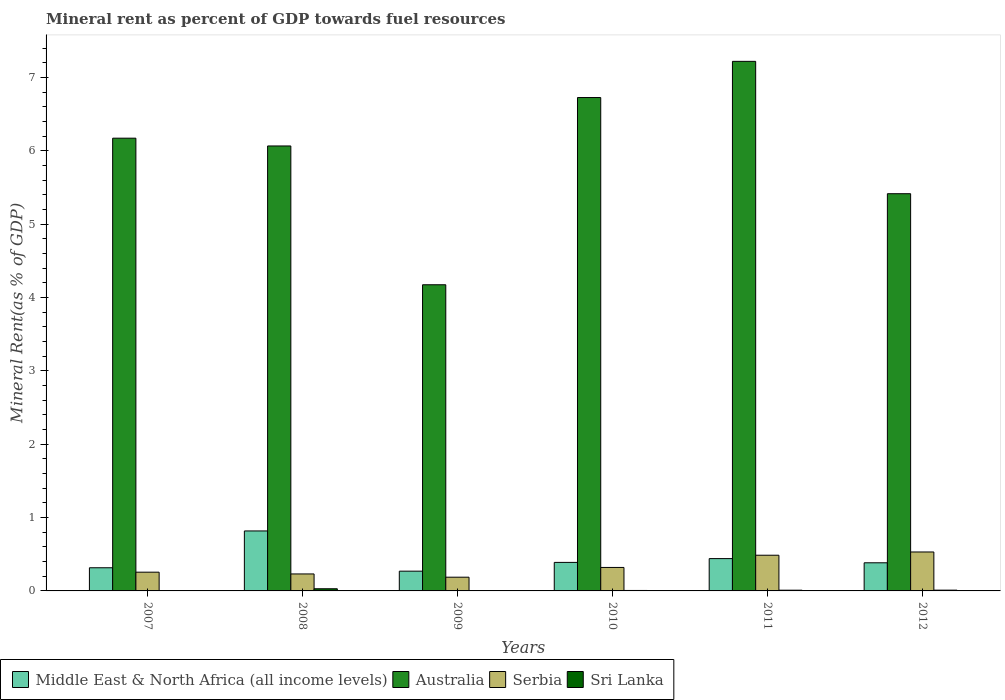How many different coloured bars are there?
Give a very brief answer. 4. Are the number of bars per tick equal to the number of legend labels?
Provide a short and direct response. Yes. How many bars are there on the 3rd tick from the right?
Offer a terse response. 4. What is the label of the 5th group of bars from the left?
Your response must be concise. 2011. In how many cases, is the number of bars for a given year not equal to the number of legend labels?
Your answer should be very brief. 0. What is the mineral rent in Australia in 2009?
Keep it short and to the point. 4.17. Across all years, what is the maximum mineral rent in Middle East & North Africa (all income levels)?
Your answer should be very brief. 0.82. Across all years, what is the minimum mineral rent in Australia?
Give a very brief answer. 4.17. In which year was the mineral rent in Australia maximum?
Keep it short and to the point. 2011. What is the total mineral rent in Middle East & North Africa (all income levels) in the graph?
Provide a succinct answer. 2.62. What is the difference between the mineral rent in Serbia in 2008 and that in 2012?
Keep it short and to the point. -0.3. What is the difference between the mineral rent in Australia in 2011 and the mineral rent in Middle East & North Africa (all income levels) in 2008?
Your answer should be very brief. 6.4. What is the average mineral rent in Sri Lanka per year?
Provide a short and direct response. 0.01. In the year 2009, what is the difference between the mineral rent in Australia and mineral rent in Serbia?
Offer a very short reply. 3.99. What is the ratio of the mineral rent in Serbia in 2007 to that in 2012?
Provide a succinct answer. 0.48. What is the difference between the highest and the second highest mineral rent in Sri Lanka?
Your answer should be very brief. 0.02. What is the difference between the highest and the lowest mineral rent in Sri Lanka?
Offer a terse response. 0.03. Is the sum of the mineral rent in Australia in 2010 and 2011 greater than the maximum mineral rent in Middle East & North Africa (all income levels) across all years?
Your response must be concise. Yes. Is it the case that in every year, the sum of the mineral rent in Middle East & North Africa (all income levels) and mineral rent in Sri Lanka is greater than the sum of mineral rent in Australia and mineral rent in Serbia?
Keep it short and to the point. No. What does the 1st bar from the left in 2010 represents?
Provide a succinct answer. Middle East & North Africa (all income levels). What does the 4th bar from the right in 2012 represents?
Provide a short and direct response. Middle East & North Africa (all income levels). How many bars are there?
Your answer should be very brief. 24. Are all the bars in the graph horizontal?
Provide a succinct answer. No. How many years are there in the graph?
Offer a very short reply. 6. What is the difference between two consecutive major ticks on the Y-axis?
Offer a terse response. 1. Does the graph contain any zero values?
Your answer should be very brief. No. Does the graph contain grids?
Your answer should be very brief. No. Where does the legend appear in the graph?
Your answer should be compact. Bottom left. How are the legend labels stacked?
Ensure brevity in your answer.  Horizontal. What is the title of the graph?
Provide a short and direct response. Mineral rent as percent of GDP towards fuel resources. Does "Ecuador" appear as one of the legend labels in the graph?
Provide a short and direct response. No. What is the label or title of the Y-axis?
Your answer should be very brief. Mineral Rent(as % of GDP). What is the Mineral Rent(as % of GDP) of Middle East & North Africa (all income levels) in 2007?
Offer a very short reply. 0.32. What is the Mineral Rent(as % of GDP) of Australia in 2007?
Give a very brief answer. 6.17. What is the Mineral Rent(as % of GDP) in Serbia in 2007?
Keep it short and to the point. 0.26. What is the Mineral Rent(as % of GDP) of Sri Lanka in 2007?
Your answer should be very brief. 0. What is the Mineral Rent(as % of GDP) of Middle East & North Africa (all income levels) in 2008?
Keep it short and to the point. 0.82. What is the Mineral Rent(as % of GDP) in Australia in 2008?
Provide a succinct answer. 6.06. What is the Mineral Rent(as % of GDP) in Serbia in 2008?
Your response must be concise. 0.23. What is the Mineral Rent(as % of GDP) in Sri Lanka in 2008?
Make the answer very short. 0.03. What is the Mineral Rent(as % of GDP) of Middle East & North Africa (all income levels) in 2009?
Ensure brevity in your answer.  0.27. What is the Mineral Rent(as % of GDP) of Australia in 2009?
Your response must be concise. 4.17. What is the Mineral Rent(as % of GDP) of Serbia in 2009?
Ensure brevity in your answer.  0.19. What is the Mineral Rent(as % of GDP) in Sri Lanka in 2009?
Ensure brevity in your answer.  0.01. What is the Mineral Rent(as % of GDP) of Middle East & North Africa (all income levels) in 2010?
Your answer should be compact. 0.39. What is the Mineral Rent(as % of GDP) in Australia in 2010?
Give a very brief answer. 6.72. What is the Mineral Rent(as % of GDP) of Serbia in 2010?
Provide a short and direct response. 0.32. What is the Mineral Rent(as % of GDP) in Sri Lanka in 2010?
Keep it short and to the point. 0.01. What is the Mineral Rent(as % of GDP) in Middle East & North Africa (all income levels) in 2011?
Offer a very short reply. 0.44. What is the Mineral Rent(as % of GDP) of Australia in 2011?
Offer a terse response. 7.22. What is the Mineral Rent(as % of GDP) of Serbia in 2011?
Offer a very short reply. 0.49. What is the Mineral Rent(as % of GDP) in Sri Lanka in 2011?
Ensure brevity in your answer.  0.01. What is the Mineral Rent(as % of GDP) of Middle East & North Africa (all income levels) in 2012?
Make the answer very short. 0.38. What is the Mineral Rent(as % of GDP) in Australia in 2012?
Make the answer very short. 5.41. What is the Mineral Rent(as % of GDP) in Serbia in 2012?
Give a very brief answer. 0.53. What is the Mineral Rent(as % of GDP) of Sri Lanka in 2012?
Give a very brief answer. 0.01. Across all years, what is the maximum Mineral Rent(as % of GDP) of Middle East & North Africa (all income levels)?
Offer a terse response. 0.82. Across all years, what is the maximum Mineral Rent(as % of GDP) of Australia?
Your response must be concise. 7.22. Across all years, what is the maximum Mineral Rent(as % of GDP) in Serbia?
Provide a short and direct response. 0.53. Across all years, what is the maximum Mineral Rent(as % of GDP) in Sri Lanka?
Your answer should be very brief. 0.03. Across all years, what is the minimum Mineral Rent(as % of GDP) in Middle East & North Africa (all income levels)?
Keep it short and to the point. 0.27. Across all years, what is the minimum Mineral Rent(as % of GDP) of Australia?
Offer a terse response. 4.17. Across all years, what is the minimum Mineral Rent(as % of GDP) of Serbia?
Keep it short and to the point. 0.19. Across all years, what is the minimum Mineral Rent(as % of GDP) in Sri Lanka?
Offer a terse response. 0. What is the total Mineral Rent(as % of GDP) in Middle East & North Africa (all income levels) in the graph?
Offer a very short reply. 2.62. What is the total Mineral Rent(as % of GDP) in Australia in the graph?
Ensure brevity in your answer.  35.77. What is the total Mineral Rent(as % of GDP) of Serbia in the graph?
Give a very brief answer. 2.01. What is the total Mineral Rent(as % of GDP) of Sri Lanka in the graph?
Your response must be concise. 0.06. What is the difference between the Mineral Rent(as % of GDP) of Middle East & North Africa (all income levels) in 2007 and that in 2008?
Make the answer very short. -0.5. What is the difference between the Mineral Rent(as % of GDP) in Australia in 2007 and that in 2008?
Offer a terse response. 0.11. What is the difference between the Mineral Rent(as % of GDP) of Serbia in 2007 and that in 2008?
Keep it short and to the point. 0.02. What is the difference between the Mineral Rent(as % of GDP) in Sri Lanka in 2007 and that in 2008?
Your answer should be compact. -0.03. What is the difference between the Mineral Rent(as % of GDP) in Middle East & North Africa (all income levels) in 2007 and that in 2009?
Make the answer very short. 0.05. What is the difference between the Mineral Rent(as % of GDP) of Australia in 2007 and that in 2009?
Offer a very short reply. 2. What is the difference between the Mineral Rent(as % of GDP) of Serbia in 2007 and that in 2009?
Your response must be concise. 0.07. What is the difference between the Mineral Rent(as % of GDP) of Sri Lanka in 2007 and that in 2009?
Make the answer very short. -0. What is the difference between the Mineral Rent(as % of GDP) in Middle East & North Africa (all income levels) in 2007 and that in 2010?
Offer a very short reply. -0.07. What is the difference between the Mineral Rent(as % of GDP) in Australia in 2007 and that in 2010?
Your answer should be very brief. -0.55. What is the difference between the Mineral Rent(as % of GDP) of Serbia in 2007 and that in 2010?
Give a very brief answer. -0.06. What is the difference between the Mineral Rent(as % of GDP) in Sri Lanka in 2007 and that in 2010?
Offer a very short reply. -0. What is the difference between the Mineral Rent(as % of GDP) in Middle East & North Africa (all income levels) in 2007 and that in 2011?
Provide a short and direct response. -0.12. What is the difference between the Mineral Rent(as % of GDP) in Australia in 2007 and that in 2011?
Your response must be concise. -1.05. What is the difference between the Mineral Rent(as % of GDP) of Serbia in 2007 and that in 2011?
Your answer should be very brief. -0.23. What is the difference between the Mineral Rent(as % of GDP) of Sri Lanka in 2007 and that in 2011?
Your answer should be compact. -0.01. What is the difference between the Mineral Rent(as % of GDP) of Middle East & North Africa (all income levels) in 2007 and that in 2012?
Ensure brevity in your answer.  -0.07. What is the difference between the Mineral Rent(as % of GDP) of Australia in 2007 and that in 2012?
Offer a very short reply. 0.76. What is the difference between the Mineral Rent(as % of GDP) of Serbia in 2007 and that in 2012?
Provide a succinct answer. -0.28. What is the difference between the Mineral Rent(as % of GDP) in Sri Lanka in 2007 and that in 2012?
Ensure brevity in your answer.  -0.01. What is the difference between the Mineral Rent(as % of GDP) in Middle East & North Africa (all income levels) in 2008 and that in 2009?
Offer a very short reply. 0.55. What is the difference between the Mineral Rent(as % of GDP) of Australia in 2008 and that in 2009?
Keep it short and to the point. 1.89. What is the difference between the Mineral Rent(as % of GDP) of Serbia in 2008 and that in 2009?
Keep it short and to the point. 0.04. What is the difference between the Mineral Rent(as % of GDP) in Sri Lanka in 2008 and that in 2009?
Your response must be concise. 0.02. What is the difference between the Mineral Rent(as % of GDP) in Middle East & North Africa (all income levels) in 2008 and that in 2010?
Your answer should be compact. 0.43. What is the difference between the Mineral Rent(as % of GDP) in Australia in 2008 and that in 2010?
Your response must be concise. -0.66. What is the difference between the Mineral Rent(as % of GDP) of Serbia in 2008 and that in 2010?
Give a very brief answer. -0.09. What is the difference between the Mineral Rent(as % of GDP) in Sri Lanka in 2008 and that in 2010?
Provide a short and direct response. 0.02. What is the difference between the Mineral Rent(as % of GDP) of Middle East & North Africa (all income levels) in 2008 and that in 2011?
Offer a terse response. 0.38. What is the difference between the Mineral Rent(as % of GDP) of Australia in 2008 and that in 2011?
Give a very brief answer. -1.15. What is the difference between the Mineral Rent(as % of GDP) of Serbia in 2008 and that in 2011?
Keep it short and to the point. -0.26. What is the difference between the Mineral Rent(as % of GDP) in Sri Lanka in 2008 and that in 2011?
Your response must be concise. 0.02. What is the difference between the Mineral Rent(as % of GDP) of Middle East & North Africa (all income levels) in 2008 and that in 2012?
Offer a very short reply. 0.43. What is the difference between the Mineral Rent(as % of GDP) of Australia in 2008 and that in 2012?
Your response must be concise. 0.65. What is the difference between the Mineral Rent(as % of GDP) of Serbia in 2008 and that in 2012?
Give a very brief answer. -0.3. What is the difference between the Mineral Rent(as % of GDP) in Sri Lanka in 2008 and that in 2012?
Offer a very short reply. 0.02. What is the difference between the Mineral Rent(as % of GDP) in Middle East & North Africa (all income levels) in 2009 and that in 2010?
Ensure brevity in your answer.  -0.12. What is the difference between the Mineral Rent(as % of GDP) in Australia in 2009 and that in 2010?
Your response must be concise. -2.55. What is the difference between the Mineral Rent(as % of GDP) of Serbia in 2009 and that in 2010?
Make the answer very short. -0.13. What is the difference between the Mineral Rent(as % of GDP) in Sri Lanka in 2009 and that in 2010?
Your answer should be compact. -0. What is the difference between the Mineral Rent(as % of GDP) of Middle East & North Africa (all income levels) in 2009 and that in 2011?
Give a very brief answer. -0.17. What is the difference between the Mineral Rent(as % of GDP) in Australia in 2009 and that in 2011?
Make the answer very short. -3.05. What is the difference between the Mineral Rent(as % of GDP) of Serbia in 2009 and that in 2011?
Provide a succinct answer. -0.3. What is the difference between the Mineral Rent(as % of GDP) of Sri Lanka in 2009 and that in 2011?
Give a very brief answer. -0. What is the difference between the Mineral Rent(as % of GDP) of Middle East & North Africa (all income levels) in 2009 and that in 2012?
Provide a succinct answer. -0.11. What is the difference between the Mineral Rent(as % of GDP) in Australia in 2009 and that in 2012?
Ensure brevity in your answer.  -1.24. What is the difference between the Mineral Rent(as % of GDP) of Serbia in 2009 and that in 2012?
Your answer should be compact. -0.34. What is the difference between the Mineral Rent(as % of GDP) of Sri Lanka in 2009 and that in 2012?
Keep it short and to the point. -0. What is the difference between the Mineral Rent(as % of GDP) of Middle East & North Africa (all income levels) in 2010 and that in 2011?
Keep it short and to the point. -0.05. What is the difference between the Mineral Rent(as % of GDP) of Australia in 2010 and that in 2011?
Your answer should be compact. -0.49. What is the difference between the Mineral Rent(as % of GDP) in Serbia in 2010 and that in 2011?
Offer a very short reply. -0.17. What is the difference between the Mineral Rent(as % of GDP) in Sri Lanka in 2010 and that in 2011?
Offer a very short reply. -0. What is the difference between the Mineral Rent(as % of GDP) of Middle East & North Africa (all income levels) in 2010 and that in 2012?
Ensure brevity in your answer.  0.01. What is the difference between the Mineral Rent(as % of GDP) of Australia in 2010 and that in 2012?
Keep it short and to the point. 1.31. What is the difference between the Mineral Rent(as % of GDP) of Serbia in 2010 and that in 2012?
Make the answer very short. -0.21. What is the difference between the Mineral Rent(as % of GDP) of Sri Lanka in 2010 and that in 2012?
Your response must be concise. -0. What is the difference between the Mineral Rent(as % of GDP) of Middle East & North Africa (all income levels) in 2011 and that in 2012?
Your answer should be very brief. 0.06. What is the difference between the Mineral Rent(as % of GDP) in Australia in 2011 and that in 2012?
Ensure brevity in your answer.  1.8. What is the difference between the Mineral Rent(as % of GDP) in Serbia in 2011 and that in 2012?
Your answer should be very brief. -0.04. What is the difference between the Mineral Rent(as % of GDP) in Sri Lanka in 2011 and that in 2012?
Ensure brevity in your answer.  -0. What is the difference between the Mineral Rent(as % of GDP) in Middle East & North Africa (all income levels) in 2007 and the Mineral Rent(as % of GDP) in Australia in 2008?
Your answer should be compact. -5.75. What is the difference between the Mineral Rent(as % of GDP) of Middle East & North Africa (all income levels) in 2007 and the Mineral Rent(as % of GDP) of Serbia in 2008?
Give a very brief answer. 0.08. What is the difference between the Mineral Rent(as % of GDP) in Middle East & North Africa (all income levels) in 2007 and the Mineral Rent(as % of GDP) in Sri Lanka in 2008?
Ensure brevity in your answer.  0.29. What is the difference between the Mineral Rent(as % of GDP) of Australia in 2007 and the Mineral Rent(as % of GDP) of Serbia in 2008?
Give a very brief answer. 5.94. What is the difference between the Mineral Rent(as % of GDP) of Australia in 2007 and the Mineral Rent(as % of GDP) of Sri Lanka in 2008?
Offer a very short reply. 6.14. What is the difference between the Mineral Rent(as % of GDP) in Serbia in 2007 and the Mineral Rent(as % of GDP) in Sri Lanka in 2008?
Provide a short and direct response. 0.23. What is the difference between the Mineral Rent(as % of GDP) of Middle East & North Africa (all income levels) in 2007 and the Mineral Rent(as % of GDP) of Australia in 2009?
Your response must be concise. -3.86. What is the difference between the Mineral Rent(as % of GDP) of Middle East & North Africa (all income levels) in 2007 and the Mineral Rent(as % of GDP) of Serbia in 2009?
Your answer should be very brief. 0.13. What is the difference between the Mineral Rent(as % of GDP) of Middle East & North Africa (all income levels) in 2007 and the Mineral Rent(as % of GDP) of Sri Lanka in 2009?
Your answer should be compact. 0.31. What is the difference between the Mineral Rent(as % of GDP) of Australia in 2007 and the Mineral Rent(as % of GDP) of Serbia in 2009?
Keep it short and to the point. 5.98. What is the difference between the Mineral Rent(as % of GDP) of Australia in 2007 and the Mineral Rent(as % of GDP) of Sri Lanka in 2009?
Offer a very short reply. 6.17. What is the difference between the Mineral Rent(as % of GDP) of Serbia in 2007 and the Mineral Rent(as % of GDP) of Sri Lanka in 2009?
Keep it short and to the point. 0.25. What is the difference between the Mineral Rent(as % of GDP) of Middle East & North Africa (all income levels) in 2007 and the Mineral Rent(as % of GDP) of Australia in 2010?
Keep it short and to the point. -6.41. What is the difference between the Mineral Rent(as % of GDP) of Middle East & North Africa (all income levels) in 2007 and the Mineral Rent(as % of GDP) of Serbia in 2010?
Ensure brevity in your answer.  -0. What is the difference between the Mineral Rent(as % of GDP) in Middle East & North Africa (all income levels) in 2007 and the Mineral Rent(as % of GDP) in Sri Lanka in 2010?
Provide a short and direct response. 0.31. What is the difference between the Mineral Rent(as % of GDP) of Australia in 2007 and the Mineral Rent(as % of GDP) of Serbia in 2010?
Offer a very short reply. 5.85. What is the difference between the Mineral Rent(as % of GDP) in Australia in 2007 and the Mineral Rent(as % of GDP) in Sri Lanka in 2010?
Give a very brief answer. 6.16. What is the difference between the Mineral Rent(as % of GDP) of Serbia in 2007 and the Mineral Rent(as % of GDP) of Sri Lanka in 2010?
Ensure brevity in your answer.  0.25. What is the difference between the Mineral Rent(as % of GDP) in Middle East & North Africa (all income levels) in 2007 and the Mineral Rent(as % of GDP) in Australia in 2011?
Keep it short and to the point. -6.9. What is the difference between the Mineral Rent(as % of GDP) in Middle East & North Africa (all income levels) in 2007 and the Mineral Rent(as % of GDP) in Serbia in 2011?
Your answer should be compact. -0.17. What is the difference between the Mineral Rent(as % of GDP) in Middle East & North Africa (all income levels) in 2007 and the Mineral Rent(as % of GDP) in Sri Lanka in 2011?
Give a very brief answer. 0.31. What is the difference between the Mineral Rent(as % of GDP) in Australia in 2007 and the Mineral Rent(as % of GDP) in Serbia in 2011?
Ensure brevity in your answer.  5.68. What is the difference between the Mineral Rent(as % of GDP) in Australia in 2007 and the Mineral Rent(as % of GDP) in Sri Lanka in 2011?
Your response must be concise. 6.16. What is the difference between the Mineral Rent(as % of GDP) of Serbia in 2007 and the Mineral Rent(as % of GDP) of Sri Lanka in 2011?
Your response must be concise. 0.25. What is the difference between the Mineral Rent(as % of GDP) in Middle East & North Africa (all income levels) in 2007 and the Mineral Rent(as % of GDP) in Australia in 2012?
Your response must be concise. -5.1. What is the difference between the Mineral Rent(as % of GDP) of Middle East & North Africa (all income levels) in 2007 and the Mineral Rent(as % of GDP) of Serbia in 2012?
Your answer should be very brief. -0.22. What is the difference between the Mineral Rent(as % of GDP) in Middle East & North Africa (all income levels) in 2007 and the Mineral Rent(as % of GDP) in Sri Lanka in 2012?
Ensure brevity in your answer.  0.31. What is the difference between the Mineral Rent(as % of GDP) of Australia in 2007 and the Mineral Rent(as % of GDP) of Serbia in 2012?
Offer a terse response. 5.64. What is the difference between the Mineral Rent(as % of GDP) of Australia in 2007 and the Mineral Rent(as % of GDP) of Sri Lanka in 2012?
Keep it short and to the point. 6.16. What is the difference between the Mineral Rent(as % of GDP) in Serbia in 2007 and the Mineral Rent(as % of GDP) in Sri Lanka in 2012?
Provide a short and direct response. 0.24. What is the difference between the Mineral Rent(as % of GDP) of Middle East & North Africa (all income levels) in 2008 and the Mineral Rent(as % of GDP) of Australia in 2009?
Offer a very short reply. -3.36. What is the difference between the Mineral Rent(as % of GDP) in Middle East & North Africa (all income levels) in 2008 and the Mineral Rent(as % of GDP) in Serbia in 2009?
Provide a short and direct response. 0.63. What is the difference between the Mineral Rent(as % of GDP) of Middle East & North Africa (all income levels) in 2008 and the Mineral Rent(as % of GDP) of Sri Lanka in 2009?
Your answer should be compact. 0.81. What is the difference between the Mineral Rent(as % of GDP) of Australia in 2008 and the Mineral Rent(as % of GDP) of Serbia in 2009?
Make the answer very short. 5.88. What is the difference between the Mineral Rent(as % of GDP) of Australia in 2008 and the Mineral Rent(as % of GDP) of Sri Lanka in 2009?
Offer a very short reply. 6.06. What is the difference between the Mineral Rent(as % of GDP) in Serbia in 2008 and the Mineral Rent(as % of GDP) in Sri Lanka in 2009?
Make the answer very short. 0.23. What is the difference between the Mineral Rent(as % of GDP) of Middle East & North Africa (all income levels) in 2008 and the Mineral Rent(as % of GDP) of Australia in 2010?
Your response must be concise. -5.91. What is the difference between the Mineral Rent(as % of GDP) of Middle East & North Africa (all income levels) in 2008 and the Mineral Rent(as % of GDP) of Serbia in 2010?
Ensure brevity in your answer.  0.5. What is the difference between the Mineral Rent(as % of GDP) of Middle East & North Africa (all income levels) in 2008 and the Mineral Rent(as % of GDP) of Sri Lanka in 2010?
Your answer should be very brief. 0.81. What is the difference between the Mineral Rent(as % of GDP) of Australia in 2008 and the Mineral Rent(as % of GDP) of Serbia in 2010?
Your response must be concise. 5.75. What is the difference between the Mineral Rent(as % of GDP) in Australia in 2008 and the Mineral Rent(as % of GDP) in Sri Lanka in 2010?
Provide a succinct answer. 6.06. What is the difference between the Mineral Rent(as % of GDP) in Serbia in 2008 and the Mineral Rent(as % of GDP) in Sri Lanka in 2010?
Give a very brief answer. 0.23. What is the difference between the Mineral Rent(as % of GDP) of Middle East & North Africa (all income levels) in 2008 and the Mineral Rent(as % of GDP) of Australia in 2011?
Offer a very short reply. -6.4. What is the difference between the Mineral Rent(as % of GDP) in Middle East & North Africa (all income levels) in 2008 and the Mineral Rent(as % of GDP) in Serbia in 2011?
Give a very brief answer. 0.33. What is the difference between the Mineral Rent(as % of GDP) in Middle East & North Africa (all income levels) in 2008 and the Mineral Rent(as % of GDP) in Sri Lanka in 2011?
Give a very brief answer. 0.81. What is the difference between the Mineral Rent(as % of GDP) in Australia in 2008 and the Mineral Rent(as % of GDP) in Serbia in 2011?
Provide a short and direct response. 5.58. What is the difference between the Mineral Rent(as % of GDP) in Australia in 2008 and the Mineral Rent(as % of GDP) in Sri Lanka in 2011?
Give a very brief answer. 6.06. What is the difference between the Mineral Rent(as % of GDP) in Serbia in 2008 and the Mineral Rent(as % of GDP) in Sri Lanka in 2011?
Your response must be concise. 0.22. What is the difference between the Mineral Rent(as % of GDP) in Middle East & North Africa (all income levels) in 2008 and the Mineral Rent(as % of GDP) in Australia in 2012?
Offer a terse response. -4.6. What is the difference between the Mineral Rent(as % of GDP) of Middle East & North Africa (all income levels) in 2008 and the Mineral Rent(as % of GDP) of Serbia in 2012?
Your answer should be very brief. 0.29. What is the difference between the Mineral Rent(as % of GDP) of Middle East & North Africa (all income levels) in 2008 and the Mineral Rent(as % of GDP) of Sri Lanka in 2012?
Keep it short and to the point. 0.81. What is the difference between the Mineral Rent(as % of GDP) of Australia in 2008 and the Mineral Rent(as % of GDP) of Serbia in 2012?
Your response must be concise. 5.53. What is the difference between the Mineral Rent(as % of GDP) of Australia in 2008 and the Mineral Rent(as % of GDP) of Sri Lanka in 2012?
Provide a succinct answer. 6.05. What is the difference between the Mineral Rent(as % of GDP) of Serbia in 2008 and the Mineral Rent(as % of GDP) of Sri Lanka in 2012?
Provide a short and direct response. 0.22. What is the difference between the Mineral Rent(as % of GDP) in Middle East & North Africa (all income levels) in 2009 and the Mineral Rent(as % of GDP) in Australia in 2010?
Your answer should be very brief. -6.46. What is the difference between the Mineral Rent(as % of GDP) in Middle East & North Africa (all income levels) in 2009 and the Mineral Rent(as % of GDP) in Serbia in 2010?
Give a very brief answer. -0.05. What is the difference between the Mineral Rent(as % of GDP) of Middle East & North Africa (all income levels) in 2009 and the Mineral Rent(as % of GDP) of Sri Lanka in 2010?
Give a very brief answer. 0.26. What is the difference between the Mineral Rent(as % of GDP) of Australia in 2009 and the Mineral Rent(as % of GDP) of Serbia in 2010?
Offer a terse response. 3.85. What is the difference between the Mineral Rent(as % of GDP) of Australia in 2009 and the Mineral Rent(as % of GDP) of Sri Lanka in 2010?
Your response must be concise. 4.17. What is the difference between the Mineral Rent(as % of GDP) of Serbia in 2009 and the Mineral Rent(as % of GDP) of Sri Lanka in 2010?
Keep it short and to the point. 0.18. What is the difference between the Mineral Rent(as % of GDP) in Middle East & North Africa (all income levels) in 2009 and the Mineral Rent(as % of GDP) in Australia in 2011?
Offer a terse response. -6.95. What is the difference between the Mineral Rent(as % of GDP) of Middle East & North Africa (all income levels) in 2009 and the Mineral Rent(as % of GDP) of Serbia in 2011?
Provide a short and direct response. -0.22. What is the difference between the Mineral Rent(as % of GDP) of Middle East & North Africa (all income levels) in 2009 and the Mineral Rent(as % of GDP) of Sri Lanka in 2011?
Make the answer very short. 0.26. What is the difference between the Mineral Rent(as % of GDP) in Australia in 2009 and the Mineral Rent(as % of GDP) in Serbia in 2011?
Ensure brevity in your answer.  3.69. What is the difference between the Mineral Rent(as % of GDP) in Australia in 2009 and the Mineral Rent(as % of GDP) in Sri Lanka in 2011?
Your answer should be very brief. 4.16. What is the difference between the Mineral Rent(as % of GDP) in Serbia in 2009 and the Mineral Rent(as % of GDP) in Sri Lanka in 2011?
Provide a short and direct response. 0.18. What is the difference between the Mineral Rent(as % of GDP) of Middle East & North Africa (all income levels) in 2009 and the Mineral Rent(as % of GDP) of Australia in 2012?
Provide a succinct answer. -5.14. What is the difference between the Mineral Rent(as % of GDP) in Middle East & North Africa (all income levels) in 2009 and the Mineral Rent(as % of GDP) in Serbia in 2012?
Provide a succinct answer. -0.26. What is the difference between the Mineral Rent(as % of GDP) in Middle East & North Africa (all income levels) in 2009 and the Mineral Rent(as % of GDP) in Sri Lanka in 2012?
Provide a short and direct response. 0.26. What is the difference between the Mineral Rent(as % of GDP) of Australia in 2009 and the Mineral Rent(as % of GDP) of Serbia in 2012?
Provide a short and direct response. 3.64. What is the difference between the Mineral Rent(as % of GDP) of Australia in 2009 and the Mineral Rent(as % of GDP) of Sri Lanka in 2012?
Your answer should be very brief. 4.16. What is the difference between the Mineral Rent(as % of GDP) in Serbia in 2009 and the Mineral Rent(as % of GDP) in Sri Lanka in 2012?
Give a very brief answer. 0.18. What is the difference between the Mineral Rent(as % of GDP) of Middle East & North Africa (all income levels) in 2010 and the Mineral Rent(as % of GDP) of Australia in 2011?
Provide a succinct answer. -6.83. What is the difference between the Mineral Rent(as % of GDP) in Middle East & North Africa (all income levels) in 2010 and the Mineral Rent(as % of GDP) in Serbia in 2011?
Provide a short and direct response. -0.1. What is the difference between the Mineral Rent(as % of GDP) of Middle East & North Africa (all income levels) in 2010 and the Mineral Rent(as % of GDP) of Sri Lanka in 2011?
Offer a very short reply. 0.38. What is the difference between the Mineral Rent(as % of GDP) of Australia in 2010 and the Mineral Rent(as % of GDP) of Serbia in 2011?
Ensure brevity in your answer.  6.24. What is the difference between the Mineral Rent(as % of GDP) in Australia in 2010 and the Mineral Rent(as % of GDP) in Sri Lanka in 2011?
Keep it short and to the point. 6.72. What is the difference between the Mineral Rent(as % of GDP) in Serbia in 2010 and the Mineral Rent(as % of GDP) in Sri Lanka in 2011?
Offer a terse response. 0.31. What is the difference between the Mineral Rent(as % of GDP) in Middle East & North Africa (all income levels) in 2010 and the Mineral Rent(as % of GDP) in Australia in 2012?
Provide a short and direct response. -5.03. What is the difference between the Mineral Rent(as % of GDP) of Middle East & North Africa (all income levels) in 2010 and the Mineral Rent(as % of GDP) of Serbia in 2012?
Your answer should be very brief. -0.14. What is the difference between the Mineral Rent(as % of GDP) of Middle East & North Africa (all income levels) in 2010 and the Mineral Rent(as % of GDP) of Sri Lanka in 2012?
Provide a succinct answer. 0.38. What is the difference between the Mineral Rent(as % of GDP) of Australia in 2010 and the Mineral Rent(as % of GDP) of Serbia in 2012?
Ensure brevity in your answer.  6.19. What is the difference between the Mineral Rent(as % of GDP) in Australia in 2010 and the Mineral Rent(as % of GDP) in Sri Lanka in 2012?
Give a very brief answer. 6.71. What is the difference between the Mineral Rent(as % of GDP) of Serbia in 2010 and the Mineral Rent(as % of GDP) of Sri Lanka in 2012?
Give a very brief answer. 0.31. What is the difference between the Mineral Rent(as % of GDP) in Middle East & North Africa (all income levels) in 2011 and the Mineral Rent(as % of GDP) in Australia in 2012?
Offer a terse response. -4.97. What is the difference between the Mineral Rent(as % of GDP) of Middle East & North Africa (all income levels) in 2011 and the Mineral Rent(as % of GDP) of Serbia in 2012?
Your answer should be very brief. -0.09. What is the difference between the Mineral Rent(as % of GDP) in Middle East & North Africa (all income levels) in 2011 and the Mineral Rent(as % of GDP) in Sri Lanka in 2012?
Your answer should be compact. 0.43. What is the difference between the Mineral Rent(as % of GDP) in Australia in 2011 and the Mineral Rent(as % of GDP) in Serbia in 2012?
Offer a terse response. 6.69. What is the difference between the Mineral Rent(as % of GDP) of Australia in 2011 and the Mineral Rent(as % of GDP) of Sri Lanka in 2012?
Offer a terse response. 7.21. What is the difference between the Mineral Rent(as % of GDP) in Serbia in 2011 and the Mineral Rent(as % of GDP) in Sri Lanka in 2012?
Make the answer very short. 0.48. What is the average Mineral Rent(as % of GDP) in Middle East & North Africa (all income levels) per year?
Your answer should be compact. 0.44. What is the average Mineral Rent(as % of GDP) in Australia per year?
Offer a very short reply. 5.96. What is the average Mineral Rent(as % of GDP) in Serbia per year?
Provide a succinct answer. 0.34. What is the average Mineral Rent(as % of GDP) of Sri Lanka per year?
Your response must be concise. 0.01. In the year 2007, what is the difference between the Mineral Rent(as % of GDP) in Middle East & North Africa (all income levels) and Mineral Rent(as % of GDP) in Australia?
Make the answer very short. -5.86. In the year 2007, what is the difference between the Mineral Rent(as % of GDP) of Middle East & North Africa (all income levels) and Mineral Rent(as % of GDP) of Serbia?
Give a very brief answer. 0.06. In the year 2007, what is the difference between the Mineral Rent(as % of GDP) in Middle East & North Africa (all income levels) and Mineral Rent(as % of GDP) in Sri Lanka?
Make the answer very short. 0.31. In the year 2007, what is the difference between the Mineral Rent(as % of GDP) in Australia and Mineral Rent(as % of GDP) in Serbia?
Offer a very short reply. 5.92. In the year 2007, what is the difference between the Mineral Rent(as % of GDP) in Australia and Mineral Rent(as % of GDP) in Sri Lanka?
Your answer should be very brief. 6.17. In the year 2007, what is the difference between the Mineral Rent(as % of GDP) of Serbia and Mineral Rent(as % of GDP) of Sri Lanka?
Offer a very short reply. 0.25. In the year 2008, what is the difference between the Mineral Rent(as % of GDP) of Middle East & North Africa (all income levels) and Mineral Rent(as % of GDP) of Australia?
Give a very brief answer. -5.25. In the year 2008, what is the difference between the Mineral Rent(as % of GDP) of Middle East & North Africa (all income levels) and Mineral Rent(as % of GDP) of Serbia?
Your answer should be compact. 0.59. In the year 2008, what is the difference between the Mineral Rent(as % of GDP) in Middle East & North Africa (all income levels) and Mineral Rent(as % of GDP) in Sri Lanka?
Your answer should be compact. 0.79. In the year 2008, what is the difference between the Mineral Rent(as % of GDP) in Australia and Mineral Rent(as % of GDP) in Serbia?
Ensure brevity in your answer.  5.83. In the year 2008, what is the difference between the Mineral Rent(as % of GDP) of Australia and Mineral Rent(as % of GDP) of Sri Lanka?
Your response must be concise. 6.04. In the year 2008, what is the difference between the Mineral Rent(as % of GDP) in Serbia and Mineral Rent(as % of GDP) in Sri Lanka?
Provide a short and direct response. 0.2. In the year 2009, what is the difference between the Mineral Rent(as % of GDP) of Middle East & North Africa (all income levels) and Mineral Rent(as % of GDP) of Australia?
Your answer should be very brief. -3.9. In the year 2009, what is the difference between the Mineral Rent(as % of GDP) in Middle East & North Africa (all income levels) and Mineral Rent(as % of GDP) in Serbia?
Ensure brevity in your answer.  0.08. In the year 2009, what is the difference between the Mineral Rent(as % of GDP) in Middle East & North Africa (all income levels) and Mineral Rent(as % of GDP) in Sri Lanka?
Your answer should be compact. 0.26. In the year 2009, what is the difference between the Mineral Rent(as % of GDP) in Australia and Mineral Rent(as % of GDP) in Serbia?
Make the answer very short. 3.99. In the year 2009, what is the difference between the Mineral Rent(as % of GDP) in Australia and Mineral Rent(as % of GDP) in Sri Lanka?
Make the answer very short. 4.17. In the year 2009, what is the difference between the Mineral Rent(as % of GDP) of Serbia and Mineral Rent(as % of GDP) of Sri Lanka?
Provide a succinct answer. 0.18. In the year 2010, what is the difference between the Mineral Rent(as % of GDP) of Middle East & North Africa (all income levels) and Mineral Rent(as % of GDP) of Australia?
Make the answer very short. -6.34. In the year 2010, what is the difference between the Mineral Rent(as % of GDP) in Middle East & North Africa (all income levels) and Mineral Rent(as % of GDP) in Serbia?
Give a very brief answer. 0.07. In the year 2010, what is the difference between the Mineral Rent(as % of GDP) in Middle East & North Africa (all income levels) and Mineral Rent(as % of GDP) in Sri Lanka?
Your response must be concise. 0.38. In the year 2010, what is the difference between the Mineral Rent(as % of GDP) of Australia and Mineral Rent(as % of GDP) of Serbia?
Make the answer very short. 6.41. In the year 2010, what is the difference between the Mineral Rent(as % of GDP) in Australia and Mineral Rent(as % of GDP) in Sri Lanka?
Offer a terse response. 6.72. In the year 2010, what is the difference between the Mineral Rent(as % of GDP) in Serbia and Mineral Rent(as % of GDP) in Sri Lanka?
Keep it short and to the point. 0.31. In the year 2011, what is the difference between the Mineral Rent(as % of GDP) of Middle East & North Africa (all income levels) and Mineral Rent(as % of GDP) of Australia?
Provide a succinct answer. -6.78. In the year 2011, what is the difference between the Mineral Rent(as % of GDP) in Middle East & North Africa (all income levels) and Mineral Rent(as % of GDP) in Serbia?
Offer a terse response. -0.05. In the year 2011, what is the difference between the Mineral Rent(as % of GDP) in Middle East & North Africa (all income levels) and Mineral Rent(as % of GDP) in Sri Lanka?
Offer a terse response. 0.43. In the year 2011, what is the difference between the Mineral Rent(as % of GDP) in Australia and Mineral Rent(as % of GDP) in Serbia?
Give a very brief answer. 6.73. In the year 2011, what is the difference between the Mineral Rent(as % of GDP) in Australia and Mineral Rent(as % of GDP) in Sri Lanka?
Your answer should be very brief. 7.21. In the year 2011, what is the difference between the Mineral Rent(as % of GDP) in Serbia and Mineral Rent(as % of GDP) in Sri Lanka?
Offer a terse response. 0.48. In the year 2012, what is the difference between the Mineral Rent(as % of GDP) in Middle East & North Africa (all income levels) and Mineral Rent(as % of GDP) in Australia?
Your answer should be compact. -5.03. In the year 2012, what is the difference between the Mineral Rent(as % of GDP) of Middle East & North Africa (all income levels) and Mineral Rent(as % of GDP) of Serbia?
Offer a very short reply. -0.15. In the year 2012, what is the difference between the Mineral Rent(as % of GDP) of Middle East & North Africa (all income levels) and Mineral Rent(as % of GDP) of Sri Lanka?
Provide a short and direct response. 0.37. In the year 2012, what is the difference between the Mineral Rent(as % of GDP) of Australia and Mineral Rent(as % of GDP) of Serbia?
Offer a terse response. 4.88. In the year 2012, what is the difference between the Mineral Rent(as % of GDP) in Australia and Mineral Rent(as % of GDP) in Sri Lanka?
Your response must be concise. 5.4. In the year 2012, what is the difference between the Mineral Rent(as % of GDP) of Serbia and Mineral Rent(as % of GDP) of Sri Lanka?
Make the answer very short. 0.52. What is the ratio of the Mineral Rent(as % of GDP) in Middle East & North Africa (all income levels) in 2007 to that in 2008?
Offer a very short reply. 0.39. What is the ratio of the Mineral Rent(as % of GDP) of Australia in 2007 to that in 2008?
Your response must be concise. 1.02. What is the ratio of the Mineral Rent(as % of GDP) in Serbia in 2007 to that in 2008?
Offer a very short reply. 1.1. What is the ratio of the Mineral Rent(as % of GDP) of Sri Lanka in 2007 to that in 2008?
Provide a succinct answer. 0.06. What is the ratio of the Mineral Rent(as % of GDP) in Middle East & North Africa (all income levels) in 2007 to that in 2009?
Ensure brevity in your answer.  1.17. What is the ratio of the Mineral Rent(as % of GDP) in Australia in 2007 to that in 2009?
Offer a very short reply. 1.48. What is the ratio of the Mineral Rent(as % of GDP) of Serbia in 2007 to that in 2009?
Provide a short and direct response. 1.37. What is the ratio of the Mineral Rent(as % of GDP) in Sri Lanka in 2007 to that in 2009?
Ensure brevity in your answer.  0.33. What is the ratio of the Mineral Rent(as % of GDP) in Middle East & North Africa (all income levels) in 2007 to that in 2010?
Keep it short and to the point. 0.81. What is the ratio of the Mineral Rent(as % of GDP) in Australia in 2007 to that in 2010?
Your response must be concise. 0.92. What is the ratio of the Mineral Rent(as % of GDP) in Serbia in 2007 to that in 2010?
Provide a short and direct response. 0.8. What is the ratio of the Mineral Rent(as % of GDP) in Sri Lanka in 2007 to that in 2010?
Provide a short and direct response. 0.3. What is the ratio of the Mineral Rent(as % of GDP) in Middle East & North Africa (all income levels) in 2007 to that in 2011?
Keep it short and to the point. 0.72. What is the ratio of the Mineral Rent(as % of GDP) in Australia in 2007 to that in 2011?
Your response must be concise. 0.85. What is the ratio of the Mineral Rent(as % of GDP) in Serbia in 2007 to that in 2011?
Keep it short and to the point. 0.53. What is the ratio of the Mineral Rent(as % of GDP) of Sri Lanka in 2007 to that in 2011?
Ensure brevity in your answer.  0.19. What is the ratio of the Mineral Rent(as % of GDP) in Middle East & North Africa (all income levels) in 2007 to that in 2012?
Give a very brief answer. 0.82. What is the ratio of the Mineral Rent(as % of GDP) in Australia in 2007 to that in 2012?
Keep it short and to the point. 1.14. What is the ratio of the Mineral Rent(as % of GDP) in Serbia in 2007 to that in 2012?
Your answer should be compact. 0.48. What is the ratio of the Mineral Rent(as % of GDP) in Sri Lanka in 2007 to that in 2012?
Offer a terse response. 0.18. What is the ratio of the Mineral Rent(as % of GDP) of Middle East & North Africa (all income levels) in 2008 to that in 2009?
Offer a very short reply. 3.04. What is the ratio of the Mineral Rent(as % of GDP) in Australia in 2008 to that in 2009?
Offer a very short reply. 1.45. What is the ratio of the Mineral Rent(as % of GDP) in Serbia in 2008 to that in 2009?
Your answer should be compact. 1.24. What is the ratio of the Mineral Rent(as % of GDP) in Sri Lanka in 2008 to that in 2009?
Your answer should be compact. 5.22. What is the ratio of the Mineral Rent(as % of GDP) in Middle East & North Africa (all income levels) in 2008 to that in 2010?
Your answer should be compact. 2.1. What is the ratio of the Mineral Rent(as % of GDP) in Australia in 2008 to that in 2010?
Provide a short and direct response. 0.9. What is the ratio of the Mineral Rent(as % of GDP) of Serbia in 2008 to that in 2010?
Your answer should be very brief. 0.72. What is the ratio of the Mineral Rent(as % of GDP) in Sri Lanka in 2008 to that in 2010?
Make the answer very short. 4.73. What is the ratio of the Mineral Rent(as % of GDP) in Middle East & North Africa (all income levels) in 2008 to that in 2011?
Your response must be concise. 1.86. What is the ratio of the Mineral Rent(as % of GDP) in Australia in 2008 to that in 2011?
Your answer should be very brief. 0.84. What is the ratio of the Mineral Rent(as % of GDP) of Serbia in 2008 to that in 2011?
Your response must be concise. 0.48. What is the ratio of the Mineral Rent(as % of GDP) in Sri Lanka in 2008 to that in 2011?
Keep it short and to the point. 2.99. What is the ratio of the Mineral Rent(as % of GDP) of Middle East & North Africa (all income levels) in 2008 to that in 2012?
Provide a succinct answer. 2.13. What is the ratio of the Mineral Rent(as % of GDP) in Australia in 2008 to that in 2012?
Give a very brief answer. 1.12. What is the ratio of the Mineral Rent(as % of GDP) of Serbia in 2008 to that in 2012?
Make the answer very short. 0.44. What is the ratio of the Mineral Rent(as % of GDP) of Sri Lanka in 2008 to that in 2012?
Your answer should be very brief. 2.79. What is the ratio of the Mineral Rent(as % of GDP) in Middle East & North Africa (all income levels) in 2009 to that in 2010?
Ensure brevity in your answer.  0.69. What is the ratio of the Mineral Rent(as % of GDP) of Australia in 2009 to that in 2010?
Keep it short and to the point. 0.62. What is the ratio of the Mineral Rent(as % of GDP) of Serbia in 2009 to that in 2010?
Make the answer very short. 0.58. What is the ratio of the Mineral Rent(as % of GDP) of Sri Lanka in 2009 to that in 2010?
Provide a short and direct response. 0.91. What is the ratio of the Mineral Rent(as % of GDP) in Middle East & North Africa (all income levels) in 2009 to that in 2011?
Ensure brevity in your answer.  0.61. What is the ratio of the Mineral Rent(as % of GDP) of Australia in 2009 to that in 2011?
Offer a terse response. 0.58. What is the ratio of the Mineral Rent(as % of GDP) in Serbia in 2009 to that in 2011?
Keep it short and to the point. 0.38. What is the ratio of the Mineral Rent(as % of GDP) of Sri Lanka in 2009 to that in 2011?
Provide a short and direct response. 0.57. What is the ratio of the Mineral Rent(as % of GDP) of Middle East & North Africa (all income levels) in 2009 to that in 2012?
Provide a succinct answer. 0.7. What is the ratio of the Mineral Rent(as % of GDP) of Australia in 2009 to that in 2012?
Offer a very short reply. 0.77. What is the ratio of the Mineral Rent(as % of GDP) of Serbia in 2009 to that in 2012?
Provide a short and direct response. 0.35. What is the ratio of the Mineral Rent(as % of GDP) of Sri Lanka in 2009 to that in 2012?
Your answer should be compact. 0.53. What is the ratio of the Mineral Rent(as % of GDP) in Middle East & North Africa (all income levels) in 2010 to that in 2011?
Give a very brief answer. 0.88. What is the ratio of the Mineral Rent(as % of GDP) of Australia in 2010 to that in 2011?
Ensure brevity in your answer.  0.93. What is the ratio of the Mineral Rent(as % of GDP) in Serbia in 2010 to that in 2011?
Keep it short and to the point. 0.66. What is the ratio of the Mineral Rent(as % of GDP) of Sri Lanka in 2010 to that in 2011?
Give a very brief answer. 0.63. What is the ratio of the Mineral Rent(as % of GDP) in Middle East & North Africa (all income levels) in 2010 to that in 2012?
Your answer should be very brief. 1.01. What is the ratio of the Mineral Rent(as % of GDP) of Australia in 2010 to that in 2012?
Offer a very short reply. 1.24. What is the ratio of the Mineral Rent(as % of GDP) in Serbia in 2010 to that in 2012?
Keep it short and to the point. 0.6. What is the ratio of the Mineral Rent(as % of GDP) of Sri Lanka in 2010 to that in 2012?
Your answer should be compact. 0.59. What is the ratio of the Mineral Rent(as % of GDP) in Middle East & North Africa (all income levels) in 2011 to that in 2012?
Provide a short and direct response. 1.15. What is the ratio of the Mineral Rent(as % of GDP) of Australia in 2011 to that in 2012?
Provide a short and direct response. 1.33. What is the ratio of the Mineral Rent(as % of GDP) of Serbia in 2011 to that in 2012?
Your answer should be very brief. 0.92. What is the ratio of the Mineral Rent(as % of GDP) in Sri Lanka in 2011 to that in 2012?
Keep it short and to the point. 0.93. What is the difference between the highest and the second highest Mineral Rent(as % of GDP) in Middle East & North Africa (all income levels)?
Your response must be concise. 0.38. What is the difference between the highest and the second highest Mineral Rent(as % of GDP) in Australia?
Make the answer very short. 0.49. What is the difference between the highest and the second highest Mineral Rent(as % of GDP) in Serbia?
Provide a short and direct response. 0.04. What is the difference between the highest and the second highest Mineral Rent(as % of GDP) of Sri Lanka?
Your answer should be very brief. 0.02. What is the difference between the highest and the lowest Mineral Rent(as % of GDP) of Middle East & North Africa (all income levels)?
Your answer should be very brief. 0.55. What is the difference between the highest and the lowest Mineral Rent(as % of GDP) in Australia?
Your answer should be very brief. 3.05. What is the difference between the highest and the lowest Mineral Rent(as % of GDP) of Serbia?
Provide a short and direct response. 0.34. What is the difference between the highest and the lowest Mineral Rent(as % of GDP) in Sri Lanka?
Your response must be concise. 0.03. 